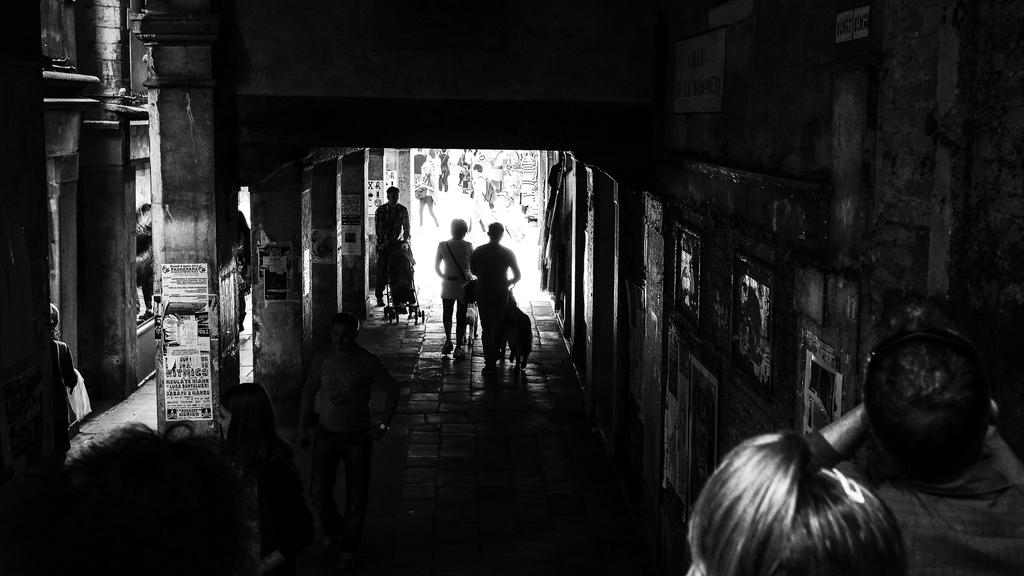Who or what can be seen in the image? There are people in the image. What are the people doing in the image? The people are walking. Where is the scene taking place? The setting is a building. What type of prose is being recited by the people in the image? There is no indication in the image that the people are reciting any prose. 